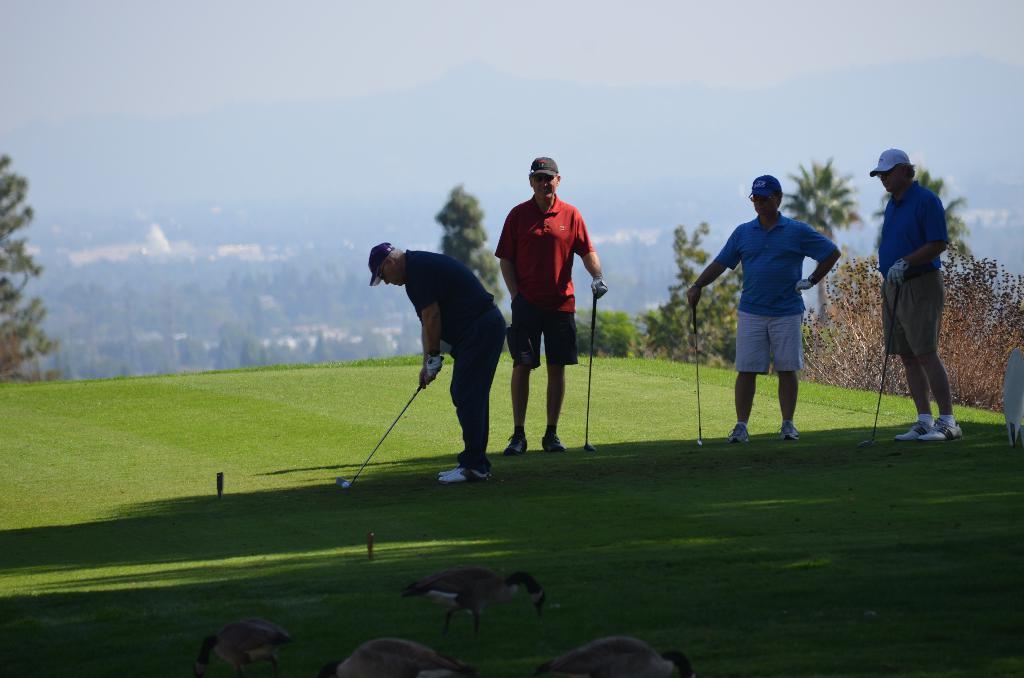Describe this image in one or two sentences. In this image I can see four persons playing game holding sticks. The person in the middle wearing red color shirt, gray color pant. At the back I can see trees in green color, sky in blue color. 